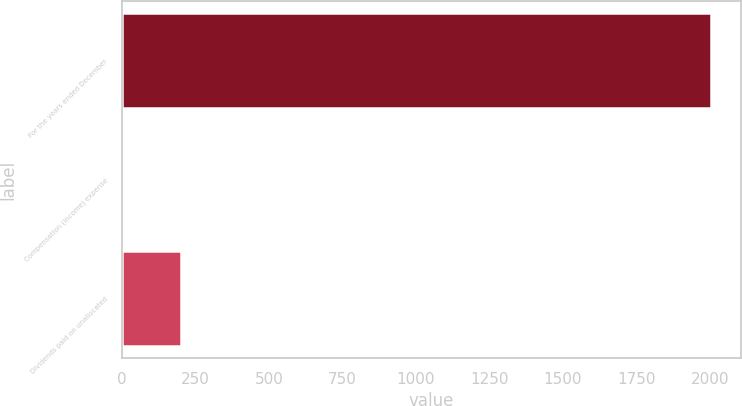<chart> <loc_0><loc_0><loc_500><loc_500><bar_chart><fcel>For the years ended December<fcel>Compensation (income) expense<fcel>Dividends paid on unallocated<nl><fcel>2005<fcel>0.4<fcel>200.86<nl></chart> 